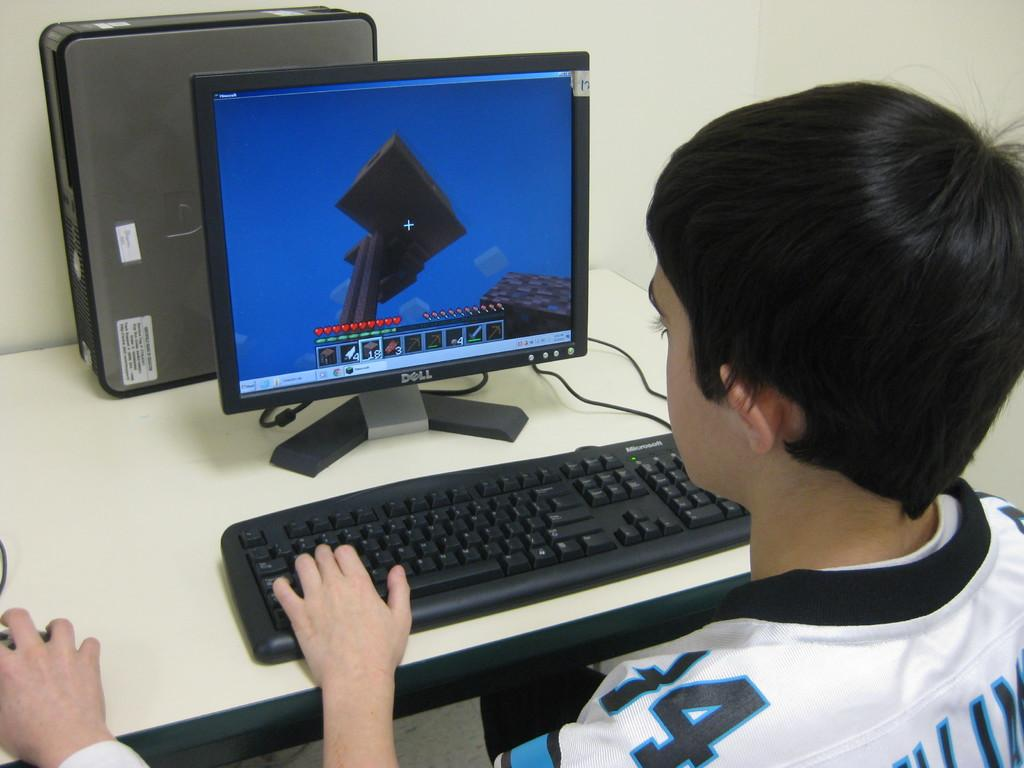<image>
Provide a brief description of the given image. A teenager enjoys watching the games he's playing on a Dell monitor. 